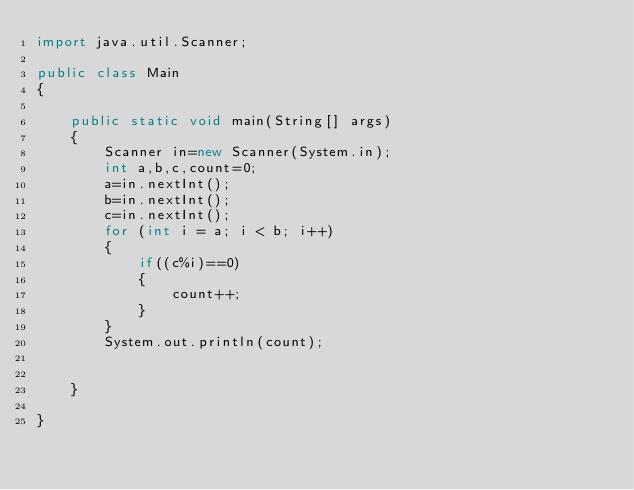Convert code to text. <code><loc_0><loc_0><loc_500><loc_500><_Java_>import java.util.Scanner;

public class Main
{

	public static void main(String[] args)
	{
		Scanner in=new Scanner(System.in);
		int a,b,c,count=0;
		a=in.nextInt();
		b=in.nextInt();
		c=in.nextInt();
		for (int i = a; i < b; i++)
		{
			if((c%i)==0)
			{
				count++;
			}			
		}
		System.out.println(count);
		

	}

}</code> 